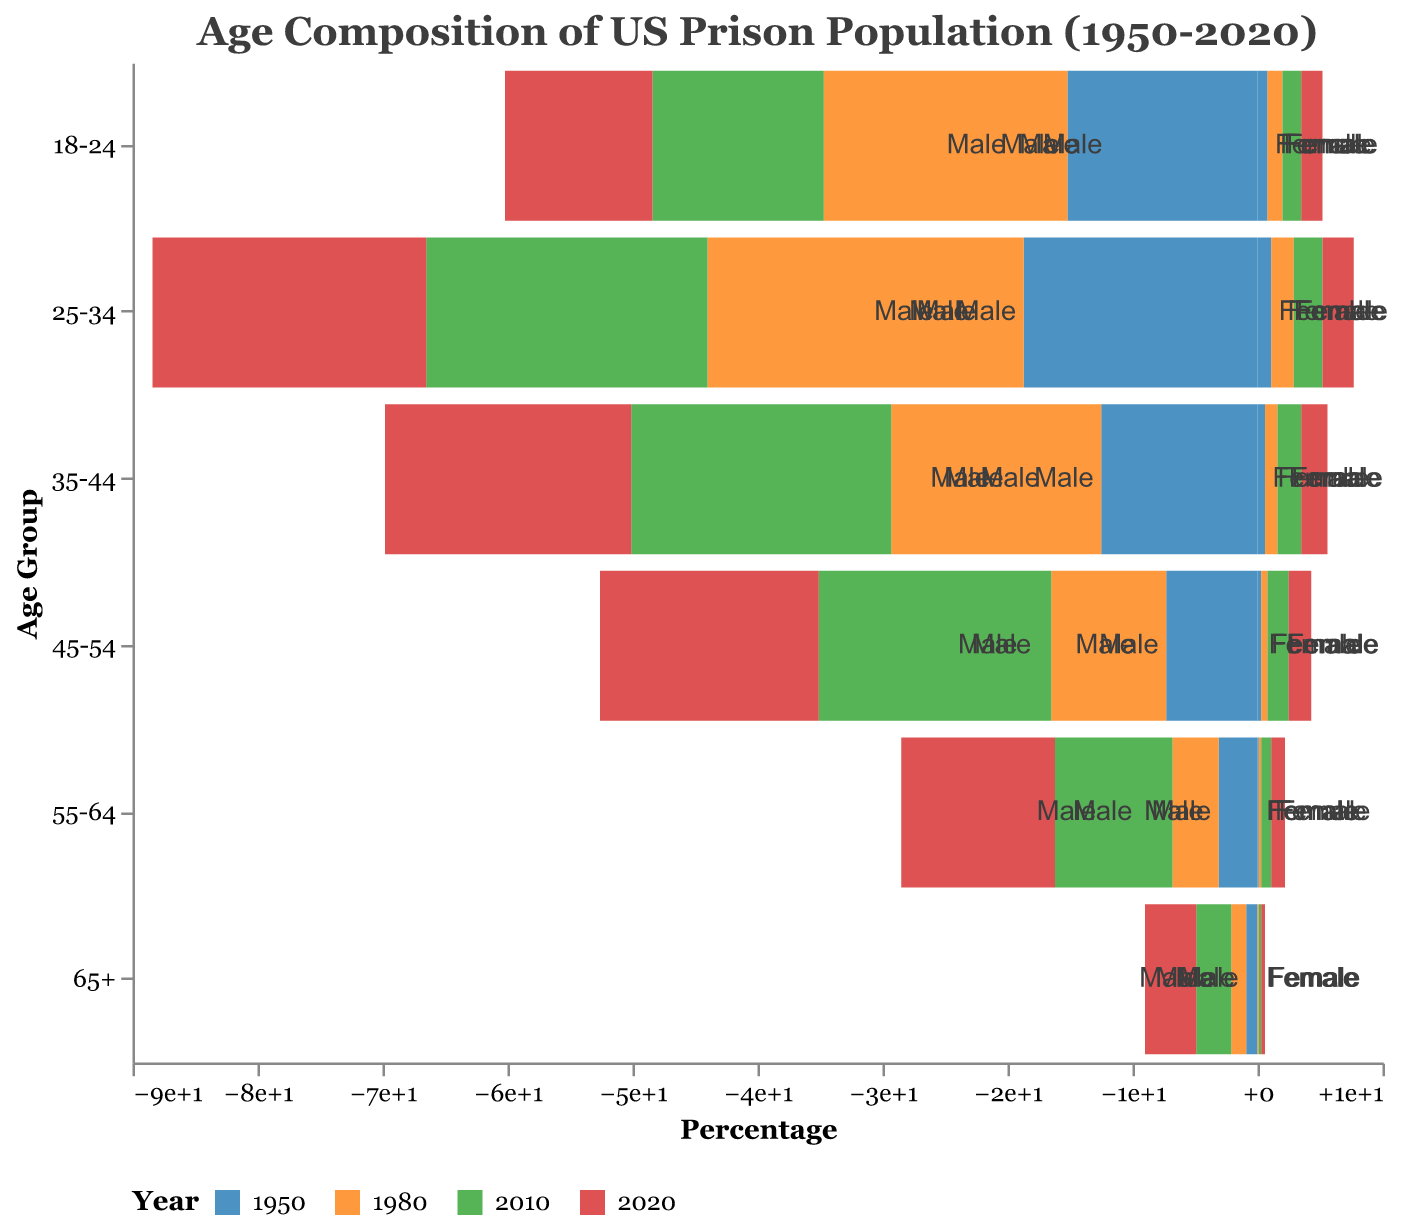What is the title of this figure? The title of a figure is typically located at the top and directly states what the visualization is about. Here, the title is "Age Composition of US Prison Population (1950-2020)", which immediately informs us that the graph depicts changes in the age distribution of the US prison population over time, from 1950 to 2020.
Answer: Age Composition of US Prison Population (1950-2020) Which age group had the highest percentage of male prisoners in 1980? To determine which age group had the highest percentage of male prisoners in 1980, look for the longest bar in the male section for the year 1980, which is marked in the second color on the legend. The 25-34 age group had the highest percentage value in the male section.
Answer: 25-34 How did the percentage of female prisoners in the age group 55-64 change from 1950 to 2020? Compare the length of the bars for females in the age group 55-64 between 1950 and 2020. Refer to the legend for the colors representing each year. The percentage increased from 0.1% in 1950 to 1.1% in 2020.
Answer: Increased by 1% Which gender and age group experienced the most significant increase in prisoner percentage from 1950 to 2010? Identify the age groups and sexes by looking at the changes in bar lengths for each respective year. For the largest increase, the age group 45-54 males saw a significant increase from 7.3% in 1950 to 18.6% in 2010.
Answer: Male, 45-54 What is the general trend in the percentage of older prisoners (65+) from 1950 to 2020? Observe the bar lengths for the 65+ age group across the years. For both genders, there is a noticeable increase, with a rise in percentage from 1950 to 2020, signifying an aging prison population.
Answer: Increasing trend Compare the percentage of male and female prisoners in the age group 25-34 in the year 2020. Examine the bar lengths for the age group 25-34 in 2020 for both males and females. The male percentage is 21.9%, while the female percentage is 2.5%.
Answer: Males: 21.9%, Females: 2.5% Between 1980 and 2020, which age group saw the largest percentage decrease in male prisoners? Review the bar lengths for each age group in 1980 and 2020, focusing on males. The age group 18-24 experienced a decrease from 19.5% in 1980 to 11.8% in 2020.
Answer: 18-24 What percentage of the total prison population is comprised of females aged 45-54 in 2010? Look at the figure for females in the 45-54 age group for the year 2010. The value given is 1.7%.
Answer: 1.7% Compare the changes in the percentages of prisoners aged 55-64 for both males and females from 1980 to 2020. Check the bar lengths for the age group 55-64 in 1980 and 2020 for both males and females. Males increased from 3.7% to 12.3%, while females increased from 0.2% to 1.1%.
Answer: Males: Increased by 8.6%, Females: Increased by 0.9% What is the most noticeable trend for the age groups younger than 35 years from 1950 to 2020? Review the percentages for age groups 18-24 and 25-34 from 1950 to 2020 for both genders. There is a noticeable decrease in these age groups, indicating fewer younger individuals in the prison population over time.
Answer: Decreasing trend 